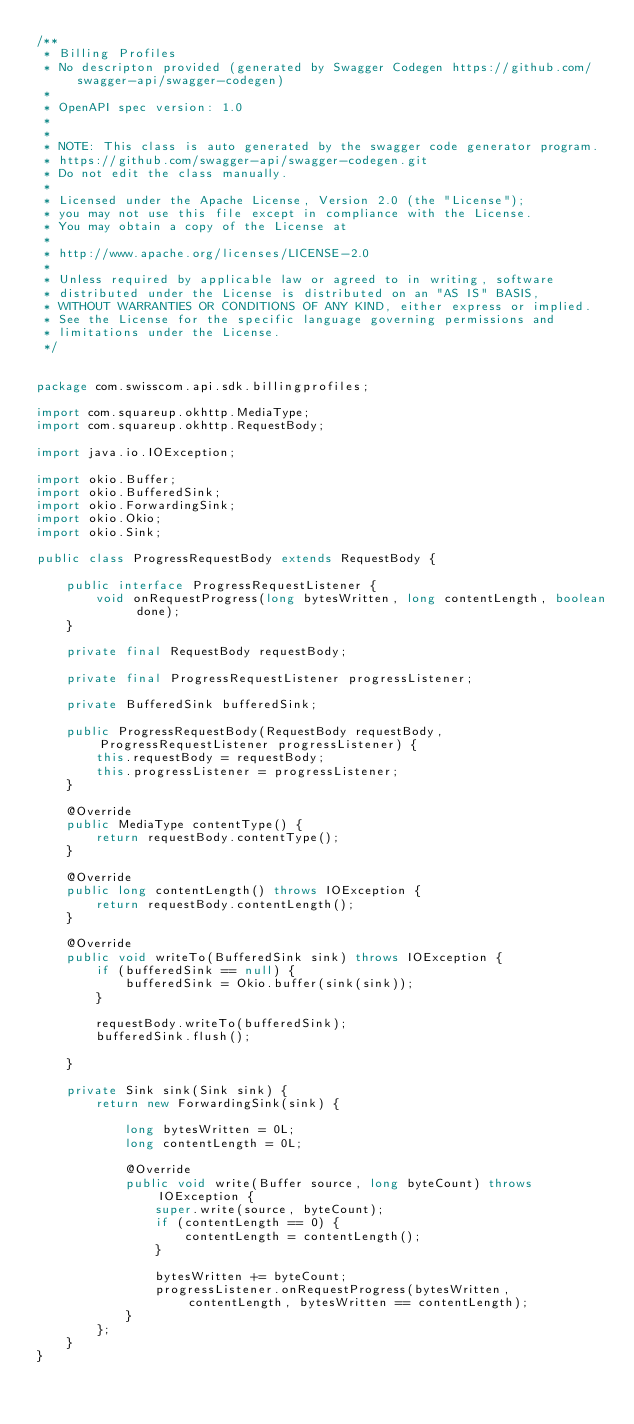Convert code to text. <code><loc_0><loc_0><loc_500><loc_500><_Java_>/**
 * Billing Profiles
 * No descripton provided (generated by Swagger Codegen https://github.com/swagger-api/swagger-codegen)
 *
 * OpenAPI spec version: 1.0
 * 
 *
 * NOTE: This class is auto generated by the swagger code generator program.
 * https://github.com/swagger-api/swagger-codegen.git
 * Do not edit the class manually.
 *
 * Licensed under the Apache License, Version 2.0 (the "License");
 * you may not use this file except in compliance with the License.
 * You may obtain a copy of the License at
 *
 * http://www.apache.org/licenses/LICENSE-2.0
 *
 * Unless required by applicable law or agreed to in writing, software
 * distributed under the License is distributed on an "AS IS" BASIS,
 * WITHOUT WARRANTIES OR CONDITIONS OF ANY KIND, either express or implied.
 * See the License for the specific language governing permissions and
 * limitations under the License.
 */


package com.swisscom.api.sdk.billingprofiles;

import com.squareup.okhttp.MediaType;
import com.squareup.okhttp.RequestBody;

import java.io.IOException;

import okio.Buffer;
import okio.BufferedSink;
import okio.ForwardingSink;
import okio.Okio;
import okio.Sink;

public class ProgressRequestBody extends RequestBody {

    public interface ProgressRequestListener {
        void onRequestProgress(long bytesWritten, long contentLength, boolean done);
    }

    private final RequestBody requestBody;

    private final ProgressRequestListener progressListener;

    private BufferedSink bufferedSink;

    public ProgressRequestBody(RequestBody requestBody, ProgressRequestListener progressListener) {
        this.requestBody = requestBody;
        this.progressListener = progressListener;
    }

    @Override
    public MediaType contentType() {
        return requestBody.contentType();
    }

    @Override
    public long contentLength() throws IOException {
        return requestBody.contentLength();
    }

    @Override
    public void writeTo(BufferedSink sink) throws IOException {
        if (bufferedSink == null) {
            bufferedSink = Okio.buffer(sink(sink));
        }

        requestBody.writeTo(bufferedSink);
        bufferedSink.flush();

    }

    private Sink sink(Sink sink) {
        return new ForwardingSink(sink) {

            long bytesWritten = 0L;
            long contentLength = 0L;

            @Override
            public void write(Buffer source, long byteCount) throws IOException {
                super.write(source, byteCount);
                if (contentLength == 0) {
                    contentLength = contentLength();
                }

                bytesWritten += byteCount;
                progressListener.onRequestProgress(bytesWritten, contentLength, bytesWritten == contentLength);
            }
        };
    }
}
</code> 